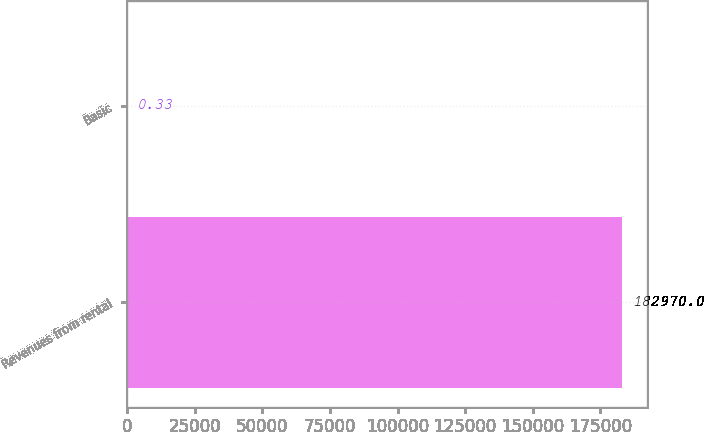Convert chart to OTSL. <chart><loc_0><loc_0><loc_500><loc_500><bar_chart><fcel>Revenues from rental<fcel>Basic<nl><fcel>182970<fcel>0.33<nl></chart> 